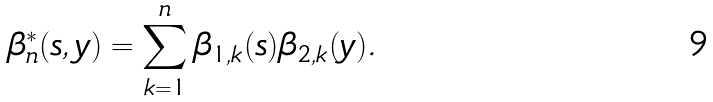Convert formula to latex. <formula><loc_0><loc_0><loc_500><loc_500>\beta _ { n } ^ { * } ( s , y ) = \sum _ { k = 1 } ^ { n } \beta _ { 1 , k } ( s ) \beta _ { 2 , k } ( y ) .</formula> 